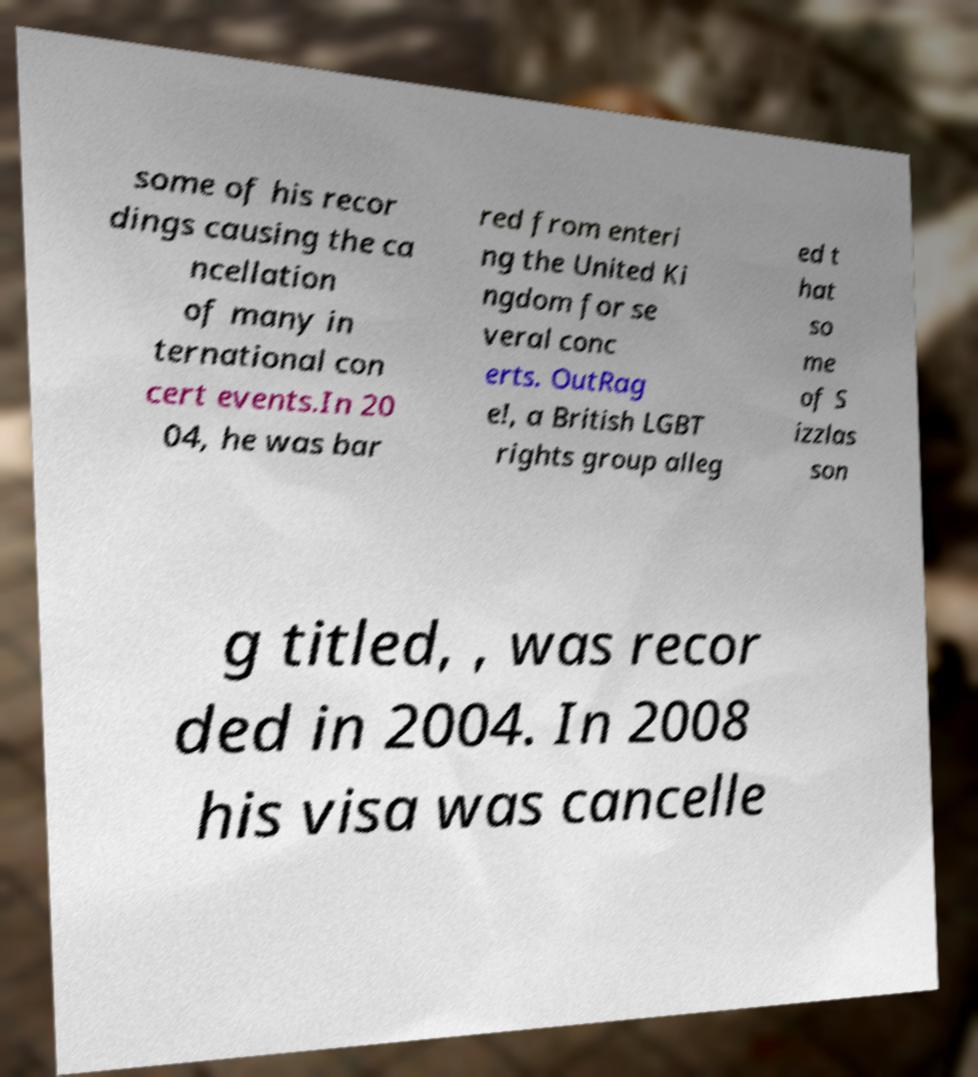Could you extract and type out the text from this image? some of his recor dings causing the ca ncellation of many in ternational con cert events.In 20 04, he was bar red from enteri ng the United Ki ngdom for se veral conc erts. OutRag e!, a British LGBT rights group alleg ed t hat so me of S izzlas son g titled, , was recor ded in 2004. In 2008 his visa was cancelle 